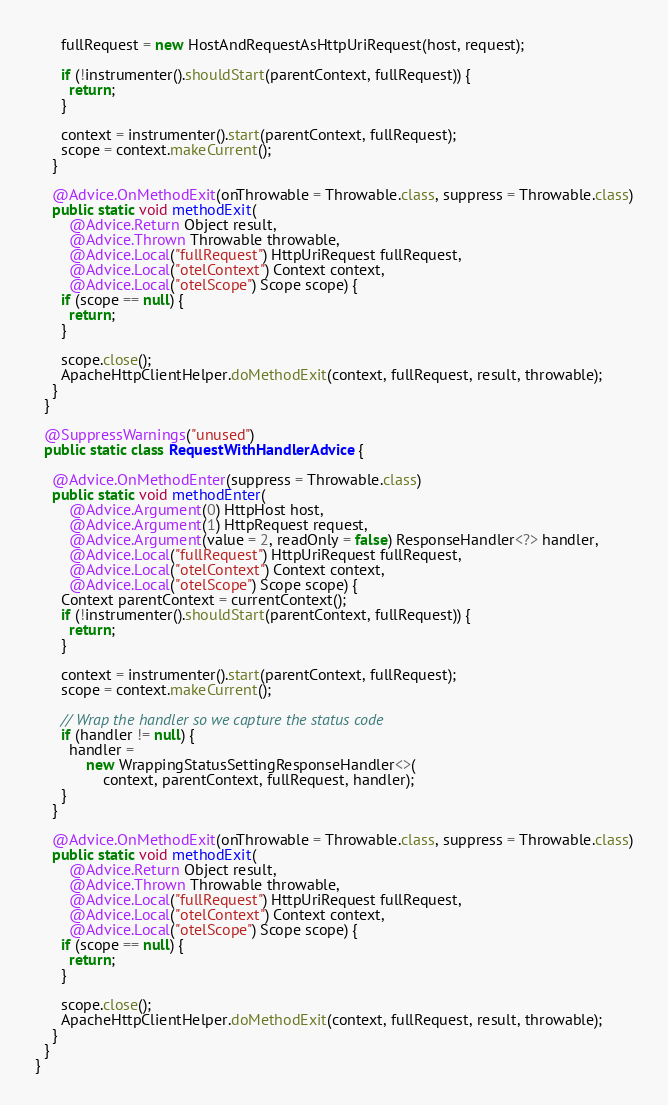Convert code to text. <code><loc_0><loc_0><loc_500><loc_500><_Java_>
      fullRequest = new HostAndRequestAsHttpUriRequest(host, request);

      if (!instrumenter().shouldStart(parentContext, fullRequest)) {
        return;
      }

      context = instrumenter().start(parentContext, fullRequest);
      scope = context.makeCurrent();
    }

    @Advice.OnMethodExit(onThrowable = Throwable.class, suppress = Throwable.class)
    public static void methodExit(
        @Advice.Return Object result,
        @Advice.Thrown Throwable throwable,
        @Advice.Local("fullRequest") HttpUriRequest fullRequest,
        @Advice.Local("otelContext") Context context,
        @Advice.Local("otelScope") Scope scope) {
      if (scope == null) {
        return;
      }

      scope.close();
      ApacheHttpClientHelper.doMethodExit(context, fullRequest, result, throwable);
    }
  }

  @SuppressWarnings("unused")
  public static class RequestWithHandlerAdvice {

    @Advice.OnMethodEnter(suppress = Throwable.class)
    public static void methodEnter(
        @Advice.Argument(0) HttpHost host,
        @Advice.Argument(1) HttpRequest request,
        @Advice.Argument(value = 2, readOnly = false) ResponseHandler<?> handler,
        @Advice.Local("fullRequest") HttpUriRequest fullRequest,
        @Advice.Local("otelContext") Context context,
        @Advice.Local("otelScope") Scope scope) {
      Context parentContext = currentContext();
      if (!instrumenter().shouldStart(parentContext, fullRequest)) {
        return;
      }

      context = instrumenter().start(parentContext, fullRequest);
      scope = context.makeCurrent();

      // Wrap the handler so we capture the status code
      if (handler != null) {
        handler =
            new WrappingStatusSettingResponseHandler<>(
                context, parentContext, fullRequest, handler);
      }
    }

    @Advice.OnMethodExit(onThrowable = Throwable.class, suppress = Throwable.class)
    public static void methodExit(
        @Advice.Return Object result,
        @Advice.Thrown Throwable throwable,
        @Advice.Local("fullRequest") HttpUriRequest fullRequest,
        @Advice.Local("otelContext") Context context,
        @Advice.Local("otelScope") Scope scope) {
      if (scope == null) {
        return;
      }

      scope.close();
      ApacheHttpClientHelper.doMethodExit(context, fullRequest, result, throwable);
    }
  }
}
</code> 